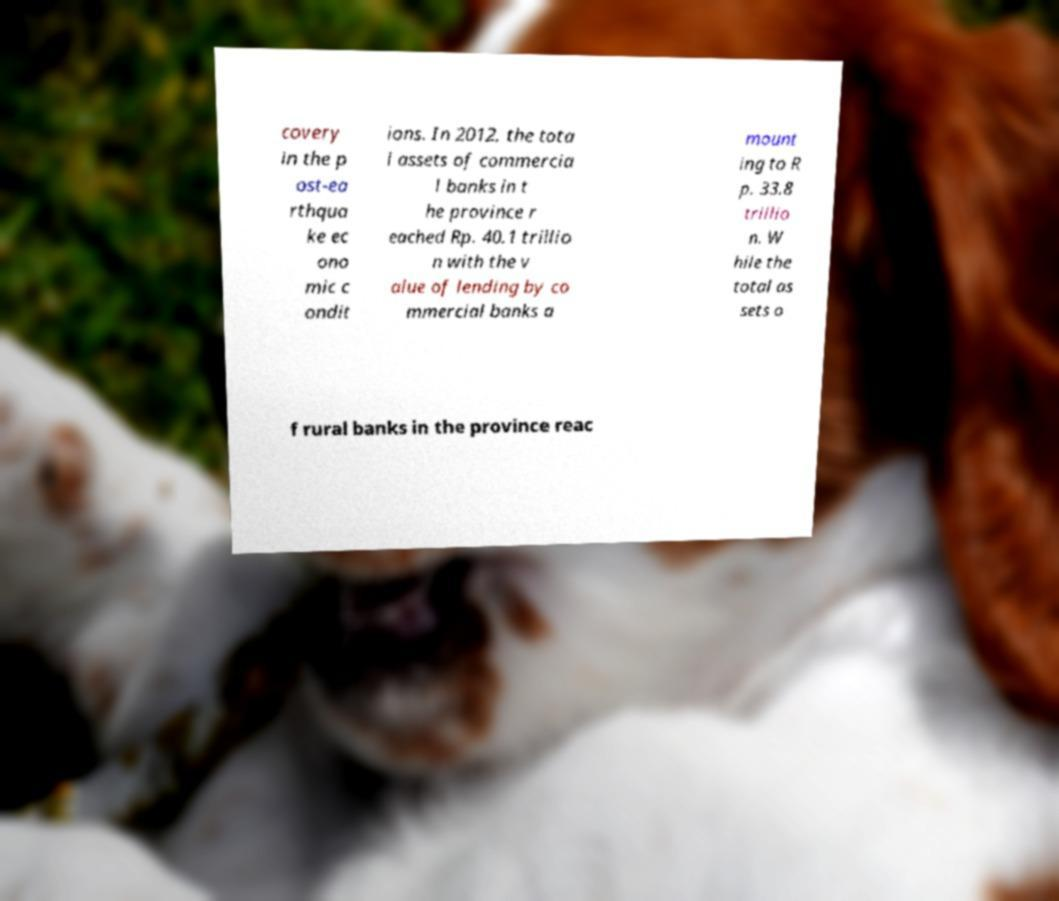Can you accurately transcribe the text from the provided image for me? covery in the p ost-ea rthqua ke ec ono mic c ondit ions. In 2012, the tota l assets of commercia l banks in t he province r eached Rp. 40.1 trillio n with the v alue of lending by co mmercial banks a mount ing to R p. 33.8 trillio n. W hile the total as sets o f rural banks in the province reac 